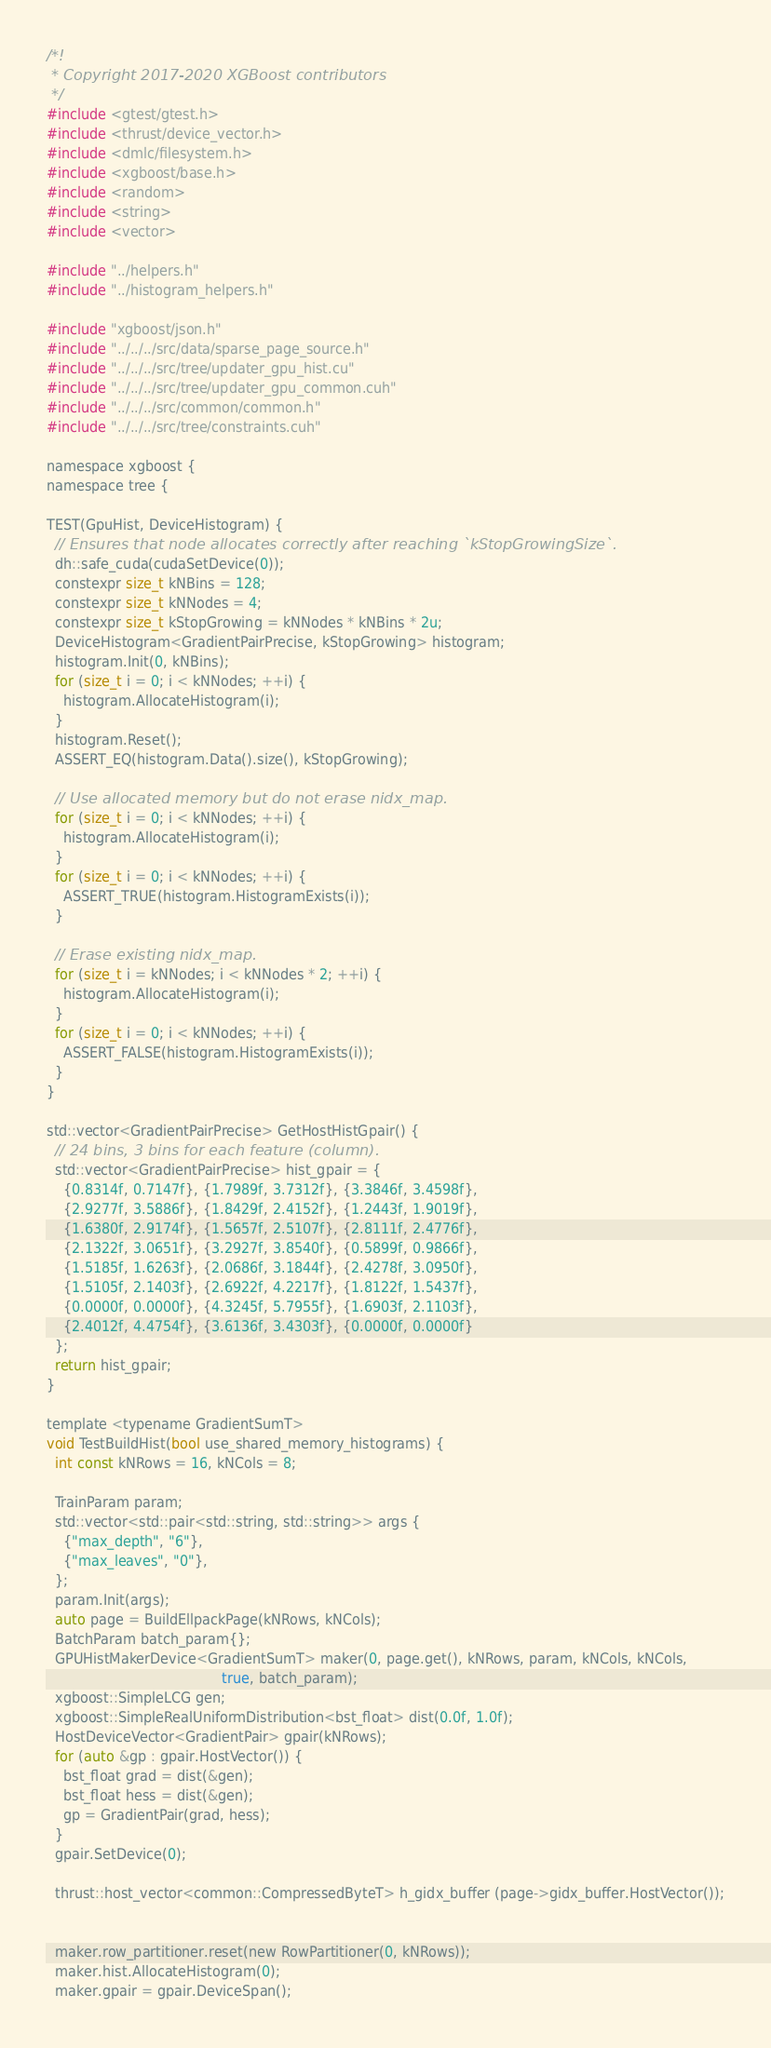<code> <loc_0><loc_0><loc_500><loc_500><_Cuda_>/*!
 * Copyright 2017-2020 XGBoost contributors
 */
#include <gtest/gtest.h>
#include <thrust/device_vector.h>
#include <dmlc/filesystem.h>
#include <xgboost/base.h>
#include <random>
#include <string>
#include <vector>

#include "../helpers.h"
#include "../histogram_helpers.h"

#include "xgboost/json.h"
#include "../../../src/data/sparse_page_source.h"
#include "../../../src/tree/updater_gpu_hist.cu"
#include "../../../src/tree/updater_gpu_common.cuh"
#include "../../../src/common/common.h"
#include "../../../src/tree/constraints.cuh"

namespace xgboost {
namespace tree {

TEST(GpuHist, DeviceHistogram) {
  // Ensures that node allocates correctly after reaching `kStopGrowingSize`.
  dh::safe_cuda(cudaSetDevice(0));
  constexpr size_t kNBins = 128;
  constexpr size_t kNNodes = 4;
  constexpr size_t kStopGrowing = kNNodes * kNBins * 2u;
  DeviceHistogram<GradientPairPrecise, kStopGrowing> histogram;
  histogram.Init(0, kNBins);
  for (size_t i = 0; i < kNNodes; ++i) {
    histogram.AllocateHistogram(i);
  }
  histogram.Reset();
  ASSERT_EQ(histogram.Data().size(), kStopGrowing);

  // Use allocated memory but do not erase nidx_map.
  for (size_t i = 0; i < kNNodes; ++i) {
    histogram.AllocateHistogram(i);
  }
  for (size_t i = 0; i < kNNodes; ++i) {
    ASSERT_TRUE(histogram.HistogramExists(i));
  }

  // Erase existing nidx_map.
  for (size_t i = kNNodes; i < kNNodes * 2; ++i) {
    histogram.AllocateHistogram(i);
  }
  for (size_t i = 0; i < kNNodes; ++i) {
    ASSERT_FALSE(histogram.HistogramExists(i));
  }
}

std::vector<GradientPairPrecise> GetHostHistGpair() {
  // 24 bins, 3 bins for each feature (column).
  std::vector<GradientPairPrecise> hist_gpair = {
    {0.8314f, 0.7147f}, {1.7989f, 3.7312f}, {3.3846f, 3.4598f},
    {2.9277f, 3.5886f}, {1.8429f, 2.4152f}, {1.2443f, 1.9019f},
    {1.6380f, 2.9174f}, {1.5657f, 2.5107f}, {2.8111f, 2.4776f},
    {2.1322f, 3.0651f}, {3.2927f, 3.8540f}, {0.5899f, 0.9866f},
    {1.5185f, 1.6263f}, {2.0686f, 3.1844f}, {2.4278f, 3.0950f},
    {1.5105f, 2.1403f}, {2.6922f, 4.2217f}, {1.8122f, 1.5437f},
    {0.0000f, 0.0000f}, {4.3245f, 5.7955f}, {1.6903f, 2.1103f},
    {2.4012f, 4.4754f}, {3.6136f, 3.4303f}, {0.0000f, 0.0000f}
  };
  return hist_gpair;
}

template <typename GradientSumT>
void TestBuildHist(bool use_shared_memory_histograms) {
  int const kNRows = 16, kNCols = 8;

  TrainParam param;
  std::vector<std::pair<std::string, std::string>> args {
    {"max_depth", "6"},
    {"max_leaves", "0"},
  };
  param.Init(args);
  auto page = BuildEllpackPage(kNRows, kNCols);
  BatchParam batch_param{};
  GPUHistMakerDevice<GradientSumT> maker(0, page.get(), kNRows, param, kNCols, kNCols,
                                         true, batch_param);
  xgboost::SimpleLCG gen;
  xgboost::SimpleRealUniformDistribution<bst_float> dist(0.0f, 1.0f);
  HostDeviceVector<GradientPair> gpair(kNRows);
  for (auto &gp : gpair.HostVector()) {
    bst_float grad = dist(&gen);
    bst_float hess = dist(&gen);
    gp = GradientPair(grad, hess);
  }
  gpair.SetDevice(0);

  thrust::host_vector<common::CompressedByteT> h_gidx_buffer (page->gidx_buffer.HostVector());


  maker.row_partitioner.reset(new RowPartitioner(0, kNRows));
  maker.hist.AllocateHistogram(0);
  maker.gpair = gpair.DeviceSpan();
</code> 